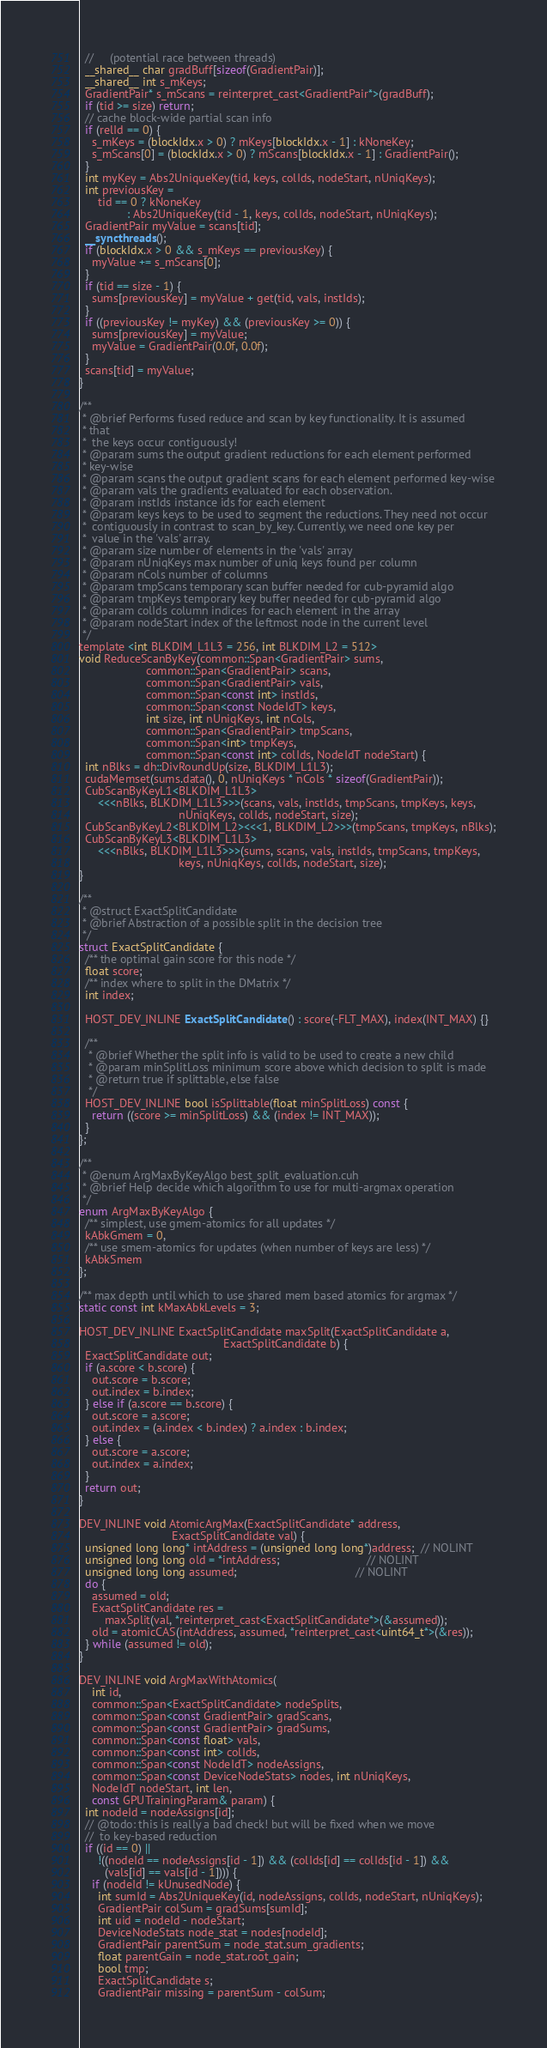Convert code to text. <code><loc_0><loc_0><loc_500><loc_500><_Cuda_>  //     (potential race between threads)
  __shared__ char gradBuff[sizeof(GradientPair)];
  __shared__ int s_mKeys;
  GradientPair* s_mScans = reinterpret_cast<GradientPair*>(gradBuff);
  if (tid >= size) return;
  // cache block-wide partial scan info
  if (relId == 0) {
    s_mKeys = (blockIdx.x > 0) ? mKeys[blockIdx.x - 1] : kNoneKey;
    s_mScans[0] = (blockIdx.x > 0) ? mScans[blockIdx.x - 1] : GradientPair();
  }
  int myKey = Abs2UniqueKey(tid, keys, colIds, nodeStart, nUniqKeys);
  int previousKey =
      tid == 0 ? kNoneKey
               : Abs2UniqueKey(tid - 1, keys, colIds, nodeStart, nUniqKeys);
  GradientPair myValue = scans[tid];
  __syncthreads();
  if (blockIdx.x > 0 && s_mKeys == previousKey) {
    myValue += s_mScans[0];
  }
  if (tid == size - 1) {
    sums[previousKey] = myValue + get(tid, vals, instIds);
  }
  if ((previousKey != myKey) && (previousKey >= 0)) {
    sums[previousKey] = myValue;
    myValue = GradientPair(0.0f, 0.0f);
  }
  scans[tid] = myValue;
}

/**
 * @brief Performs fused reduce and scan by key functionality. It is assumed
 * that
 *  the keys occur contiguously!
 * @param sums the output gradient reductions for each element performed
 * key-wise
 * @param scans the output gradient scans for each element performed key-wise
 * @param vals the gradients evaluated for each observation.
 * @param instIds instance ids for each element
 * @param keys keys to be used to segment the reductions. They need not occur
 *  contiguously in contrast to scan_by_key. Currently, we need one key per
 *  value in the 'vals' array.
 * @param size number of elements in the 'vals' array
 * @param nUniqKeys max number of uniq keys found per column
 * @param nCols number of columns
 * @param tmpScans temporary scan buffer needed for cub-pyramid algo
 * @param tmpKeys temporary key buffer needed for cub-pyramid algo
 * @param colIds column indices for each element in the array
 * @param nodeStart index of the leftmost node in the current level
 */
template <int BLKDIM_L1L3 = 256, int BLKDIM_L2 = 512>
void ReduceScanByKey(common::Span<GradientPair> sums,
                     common::Span<GradientPair> scans,
                     common::Span<GradientPair> vals,
                     common::Span<const int> instIds,
                     common::Span<const NodeIdT> keys,
                     int size, int nUniqKeys, int nCols,
                     common::Span<GradientPair> tmpScans,
                     common::Span<int> tmpKeys,
                     common::Span<const int> colIds, NodeIdT nodeStart) {
  int nBlks = dh::DivRoundUp(size, BLKDIM_L1L3);
  cudaMemset(sums.data(), 0, nUniqKeys * nCols * sizeof(GradientPair));
  CubScanByKeyL1<BLKDIM_L1L3>
      <<<nBlks, BLKDIM_L1L3>>>(scans, vals, instIds, tmpScans, tmpKeys, keys,
                               nUniqKeys, colIds, nodeStart, size);
  CubScanByKeyL2<BLKDIM_L2><<<1, BLKDIM_L2>>>(tmpScans, tmpKeys, nBlks);
  CubScanByKeyL3<BLKDIM_L1L3>
      <<<nBlks, BLKDIM_L1L3>>>(sums, scans, vals, instIds, tmpScans, tmpKeys,
                               keys, nUniqKeys, colIds, nodeStart, size);
}

/**
 * @struct ExactSplitCandidate
 * @brief Abstraction of a possible split in the decision tree
 */
struct ExactSplitCandidate {
  /** the optimal gain score for this node */
  float score;
  /** index where to split in the DMatrix */
  int index;

  HOST_DEV_INLINE ExactSplitCandidate() : score(-FLT_MAX), index(INT_MAX) {}

  /**
   * @brief Whether the split info is valid to be used to create a new child
   * @param minSplitLoss minimum score above which decision to split is made
   * @return true if splittable, else false
   */
  HOST_DEV_INLINE bool isSplittable(float minSplitLoss) const {
    return ((score >= minSplitLoss) && (index != INT_MAX));
  }
};

/**
 * @enum ArgMaxByKeyAlgo best_split_evaluation.cuh
 * @brief Help decide which algorithm to use for multi-argmax operation
 */
enum ArgMaxByKeyAlgo {
  /** simplest, use gmem-atomics for all updates */
  kAbkGmem = 0,
  /** use smem-atomics for updates (when number of keys are less) */
  kAbkSmem
};

/** max depth until which to use shared mem based atomics for argmax */
static const int kMaxAbkLevels = 3;

HOST_DEV_INLINE ExactSplitCandidate maxSplit(ExactSplitCandidate a,
                                             ExactSplitCandidate b) {
  ExactSplitCandidate out;
  if (a.score < b.score) {
    out.score = b.score;
    out.index = b.index;
  } else if (a.score == b.score) {
    out.score = a.score;
    out.index = (a.index < b.index) ? a.index : b.index;
  } else {
    out.score = a.score;
    out.index = a.index;
  }
  return out;
}

DEV_INLINE void AtomicArgMax(ExactSplitCandidate* address,
                             ExactSplitCandidate val) {
  unsigned long long* intAddress = (unsigned long long*)address;  // NOLINT
  unsigned long long old = *intAddress;                           // NOLINT
  unsigned long long assumed;                                     // NOLINT
  do {
    assumed = old;
    ExactSplitCandidate res =
        maxSplit(val, *reinterpret_cast<ExactSplitCandidate*>(&assumed));
    old = atomicCAS(intAddress, assumed, *reinterpret_cast<uint64_t*>(&res));
  } while (assumed != old);
}

DEV_INLINE void ArgMaxWithAtomics(
    int id,
    common::Span<ExactSplitCandidate> nodeSplits,
    common::Span<const GradientPair> gradScans,
    common::Span<const GradientPair> gradSums,
    common::Span<const float> vals,
    common::Span<const int> colIds,
    common::Span<const NodeIdT> nodeAssigns,
    common::Span<const DeviceNodeStats> nodes, int nUniqKeys,
    NodeIdT nodeStart, int len,
    const GPUTrainingParam& param) {
  int nodeId = nodeAssigns[id];
  // @todo: this is really a bad check! but will be fixed when we move
  //  to key-based reduction
  if ((id == 0) ||
      !((nodeId == nodeAssigns[id - 1]) && (colIds[id] == colIds[id - 1]) &&
        (vals[id] == vals[id - 1]))) {
    if (nodeId != kUnusedNode) {
      int sumId = Abs2UniqueKey(id, nodeAssigns, colIds, nodeStart, nUniqKeys);
      GradientPair colSum = gradSums[sumId];
      int uid = nodeId - nodeStart;
      DeviceNodeStats node_stat = nodes[nodeId];
      GradientPair parentSum = node_stat.sum_gradients;
      float parentGain = node_stat.root_gain;
      bool tmp;
      ExactSplitCandidate s;
      GradientPair missing = parentSum - colSum;</code> 